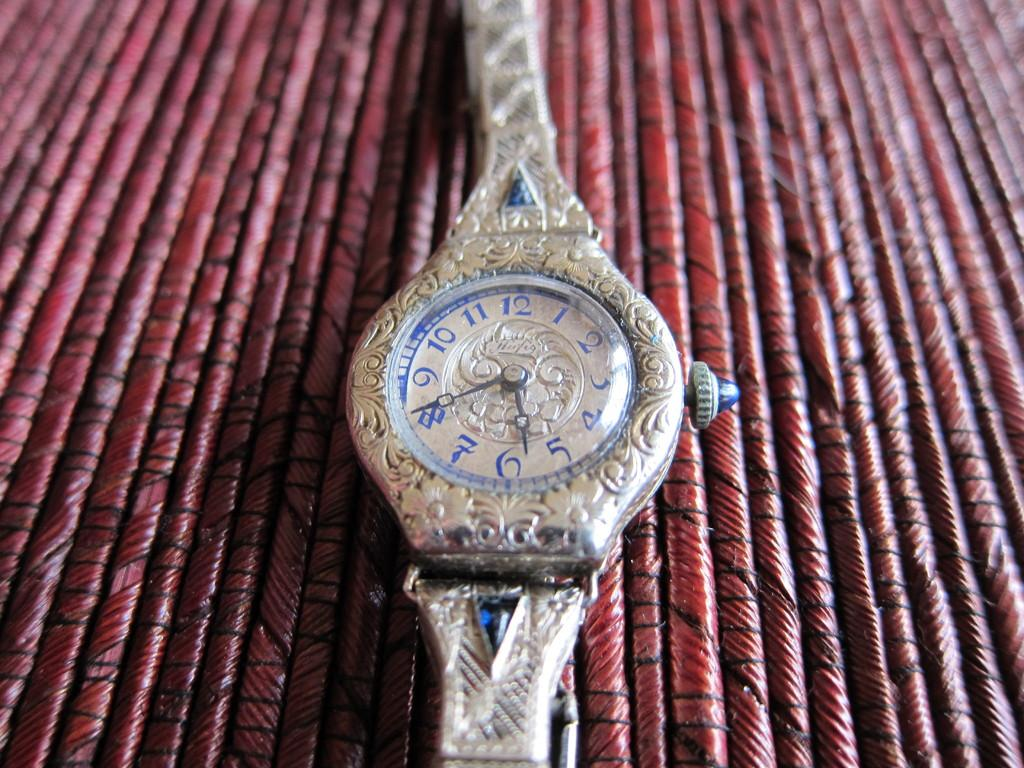<image>
Offer a succinct explanation of the picture presented. A fancy women's watch with the number 12 at the top and 6 at the bottom sits on a textured surface. 